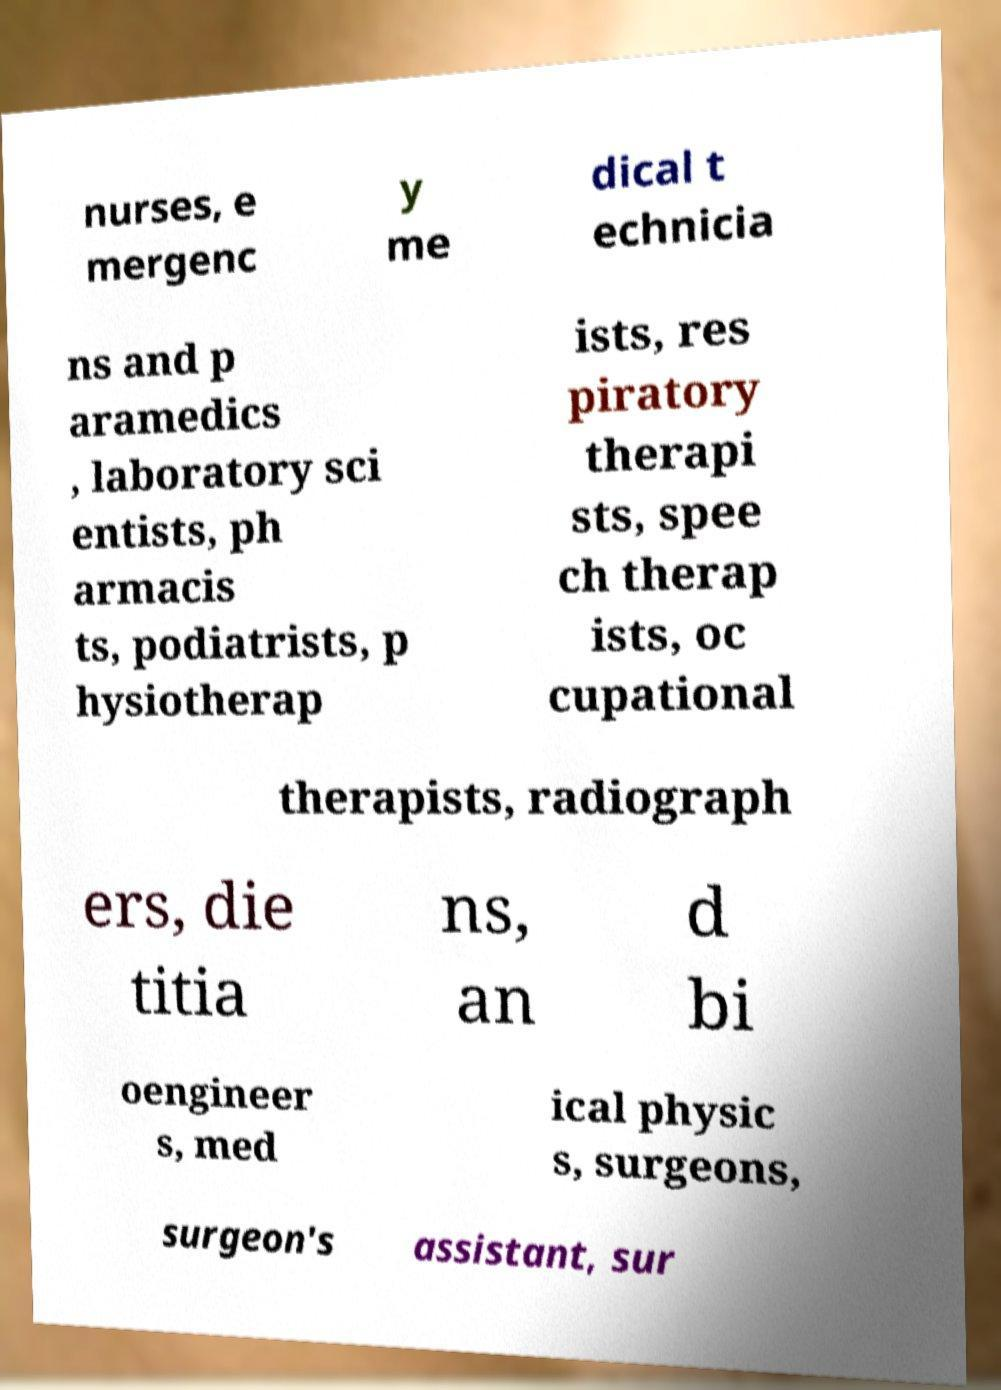Please read and relay the text visible in this image. What does it say? nurses, e mergenc y me dical t echnicia ns and p aramedics , laboratory sci entists, ph armacis ts, podiatrists, p hysiotherap ists, res piratory therapi sts, spee ch therap ists, oc cupational therapists, radiograph ers, die titia ns, an d bi oengineer s, med ical physic s, surgeons, surgeon's assistant, sur 